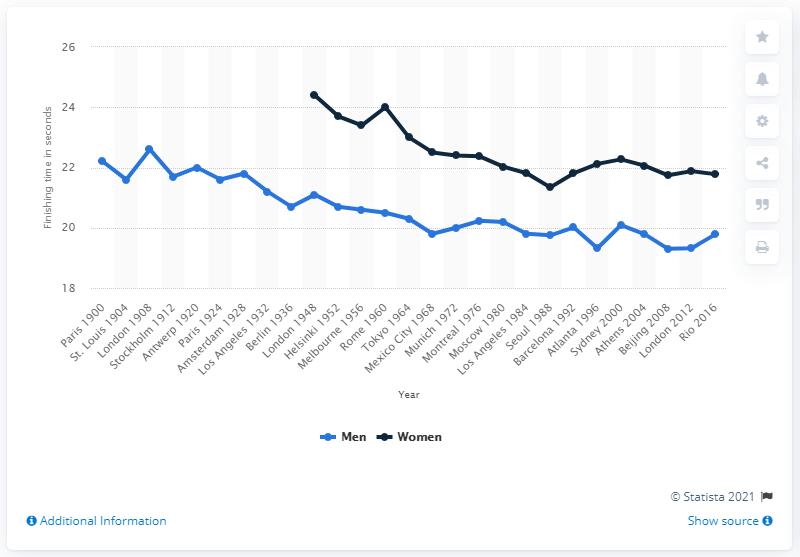Identify some key points in this picture. The women's 200 meter event was introduced at the London Olympics in 1948. The men's 200 meter sprint was officially recognized as an event at the Paris Olympics in 1900. 